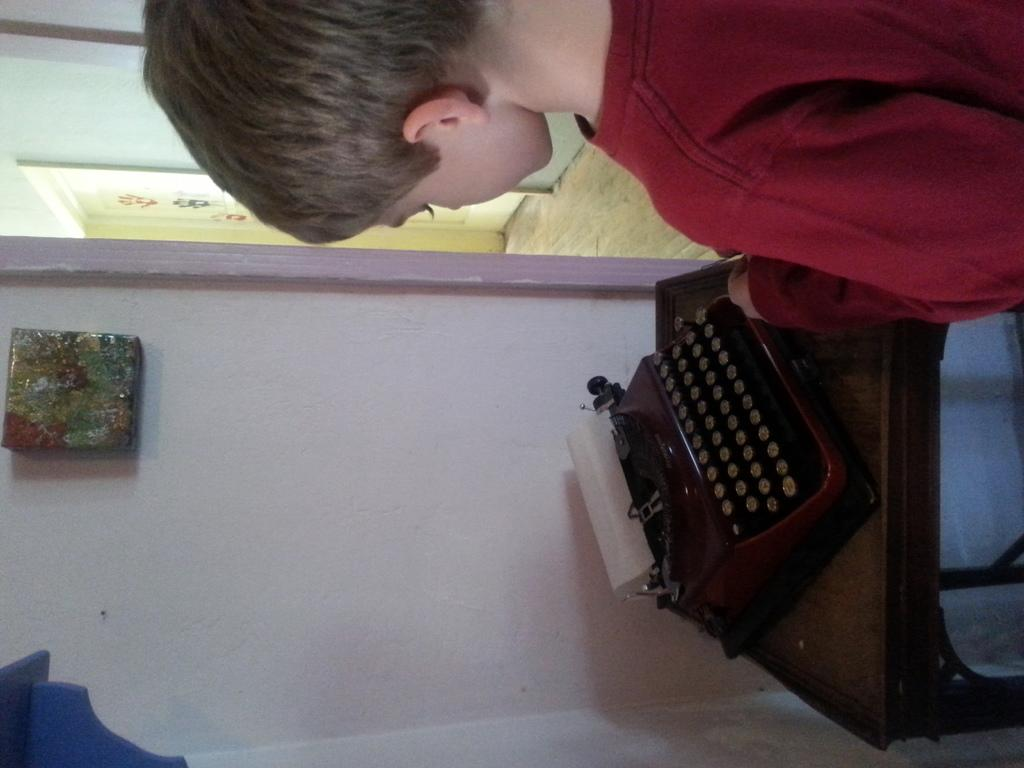Who is the main subject in the image? There is a boy in the image. What is the boy wearing? The boy is wearing clothes. What object is in front of the boy? There is a stool in front of the boy. What is on top of the stool? There is a typewriter machine on the stool. What can be seen behind the boy? There is a wall in the image. What is the surface beneath the boy's feet? There is a floor in the image. Is there any entrance or exit visible in the image? Yes, there is a door in the image. How many family members are present in the image? The provided facts do not mention any family members, so it cannot be determined from the image. What things does the boy have in his hands? The provided facts do not mention any objects in the boy's hands, so it cannot be determined from the image. 